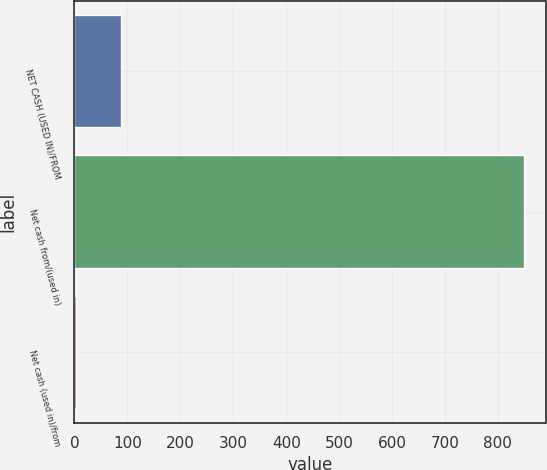Convert chart to OTSL. <chart><loc_0><loc_0><loc_500><loc_500><bar_chart><fcel>NET CASH (USED IN)/FROM<fcel>Net cash from/(used in)<fcel>Net cash (used in)/from<nl><fcel>87.6<fcel>849<fcel>3<nl></chart> 